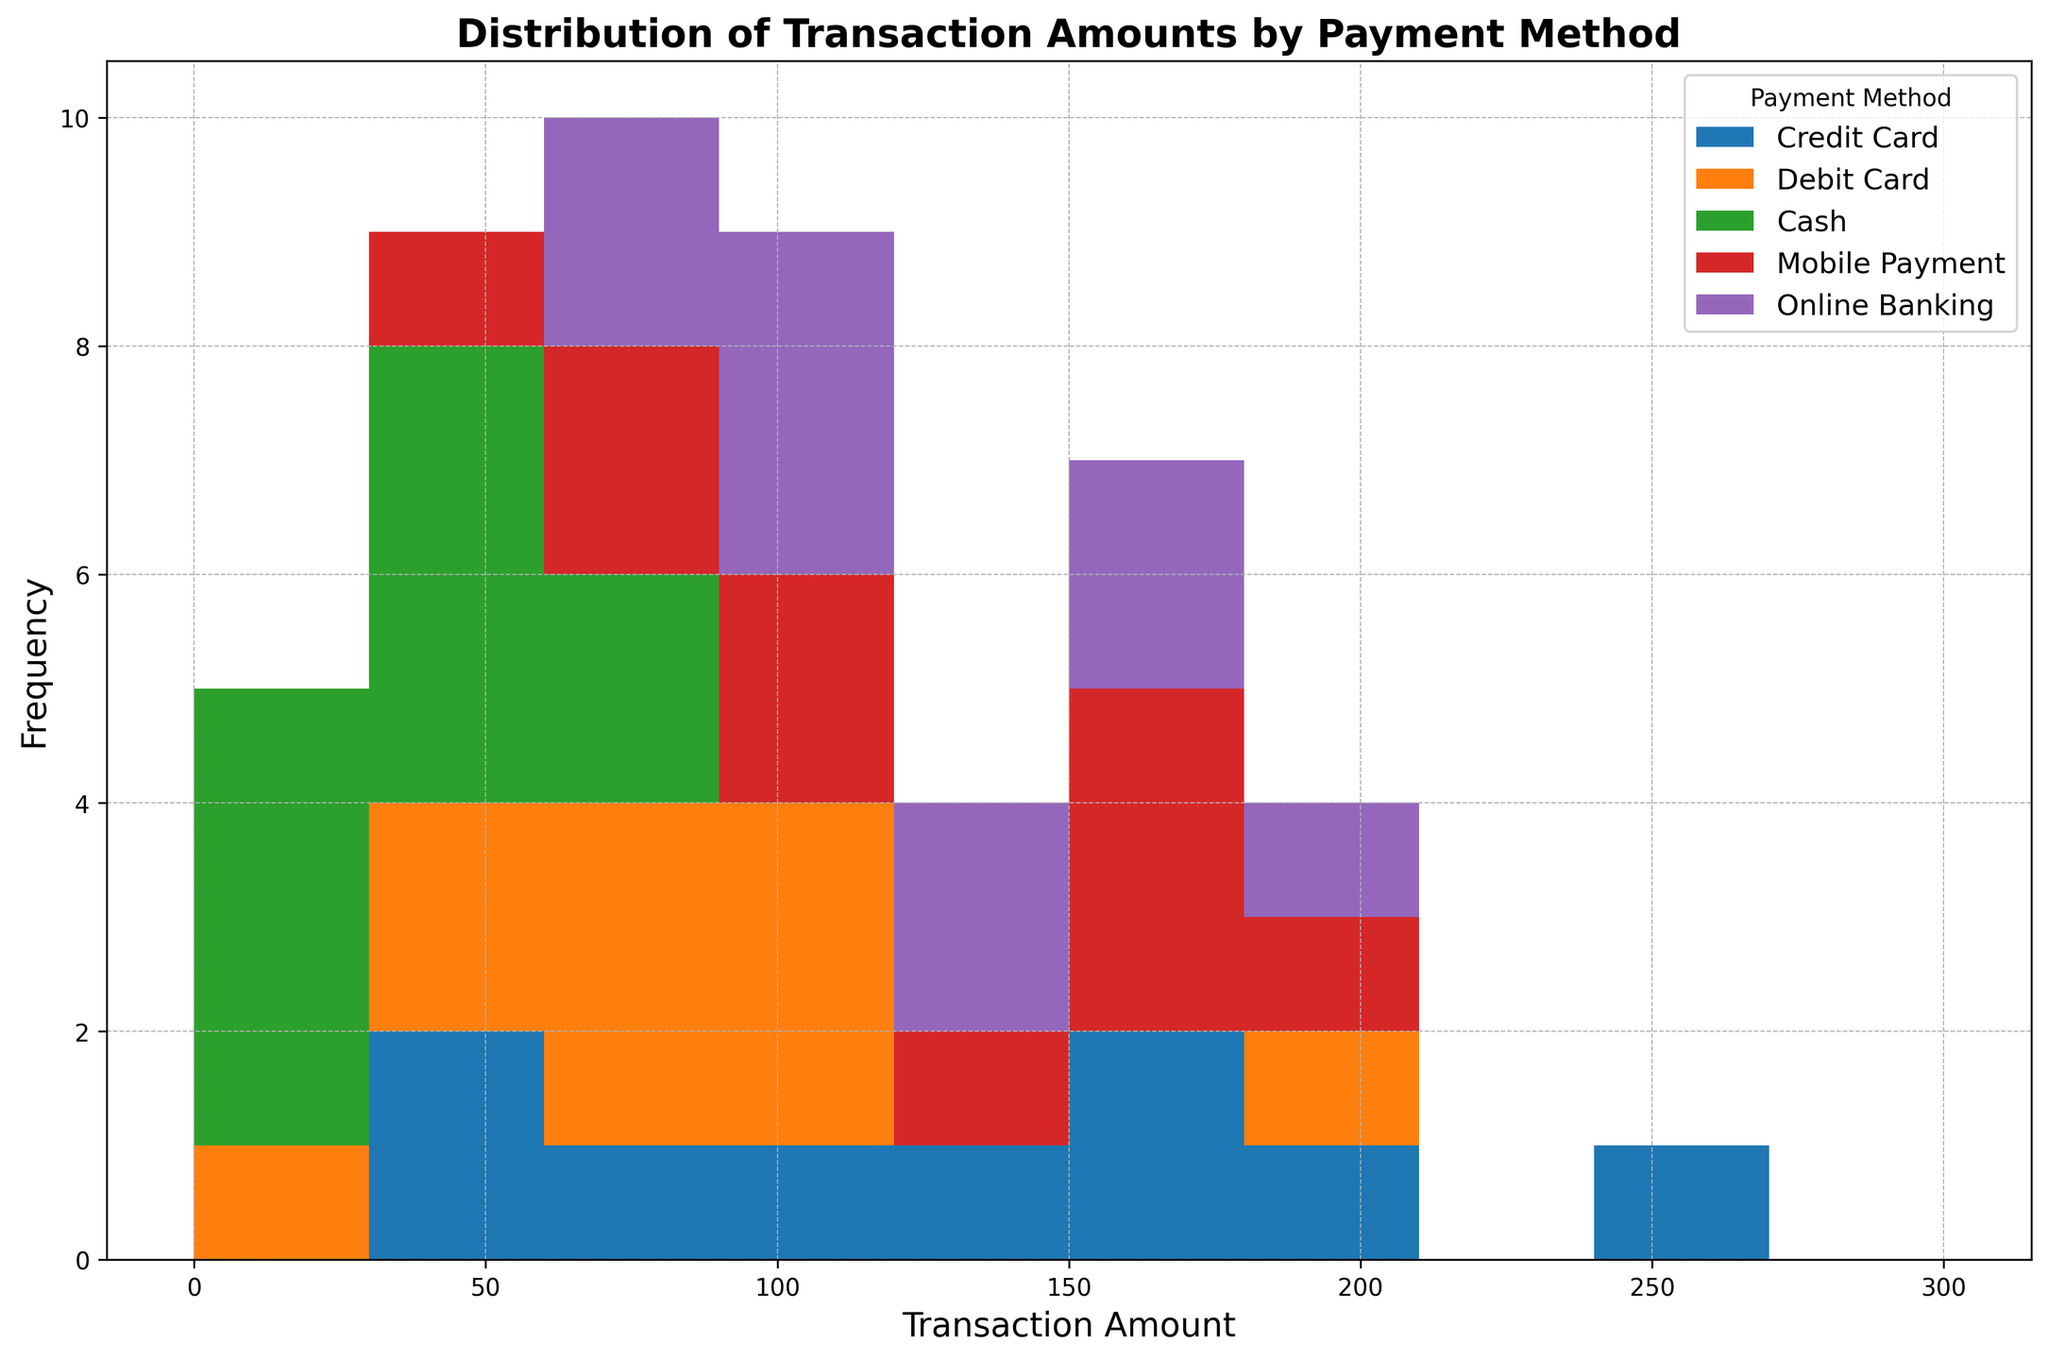What is the most frequent transaction amount range for Credit Card payments? First, locate the histogram bins related to Credit Card payments (colored in blue). Then, observe which bin has the highest bar for Credit Card.
Answer: The $50-$100 range Which payment method shows the highest frequency of transactions in the $100-$150 range? Identify the bins for the $100-$150 range. Compare the heights of the bars for different payment methods within this range.
Answer: Mobile Payment Are there any payment methods with similar transaction amount distributions? Look for payment methods that have similar shapes and heights of histograms across the transaction amount ranges. Compare the visual distributions.
Answer: Online Banking and Mobile Payment have similar distributions What is the difference in the number of transactions between the highest and lowest bins for Cash payments? Identify the highest and lowest bar heights for Cash transactions (green bars) in the histogram. Subtract the lowest count from the highest count.
Answer: 4 - 1 = 3 In which range do Debit Card transactions have their peak frequency? Locate the bars colored in orange that represent Debit Card transactions. Find the range with the tallest bar within that color.
Answer: The $40-$80 range What visual pattern represents Online Banking transactions? Identify the color used for Online Banking (purple) and describe the distribution pattern of these bars (peak ranges, spread, etc.).
Answer: Online Banking transactions are more evenly spread, but with a notable peak in the $80-$180 range Which range has no transactions shown for Cash? Examine the histogram and locate any gaps in the green bars representing Cash, identifying the transaction amount range with no green bars.
Answer: The $100-$150 range How does the frequency of transactions in the $150-$200 range compare to the $0-$50 range for Mobile Payments? Compare the heights of the bars for Mobile Payments (red) in the $150-$200 range against those in the $0-$50 range.
Answer: Higher in the $150-$200 range What is the range with the highest transaction count overall? Identify the bin with the tallest combined bar stack across all payment methods in the histogram.
Answer: The $50-$100 range In terms of transaction amount ranges, how do Credit Card and Debit Card transactions differ the most? Compare the histograms for Credit Card (blue) and Debit Card (orange) and identify the ranges with the most significant differences in bar heights between these two colors.
Answer: The $200-$250 range 